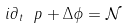<formula> <loc_0><loc_0><loc_500><loc_500>i \partial _ { t } \ p + \Delta \phi = \mathcal { N }</formula> 